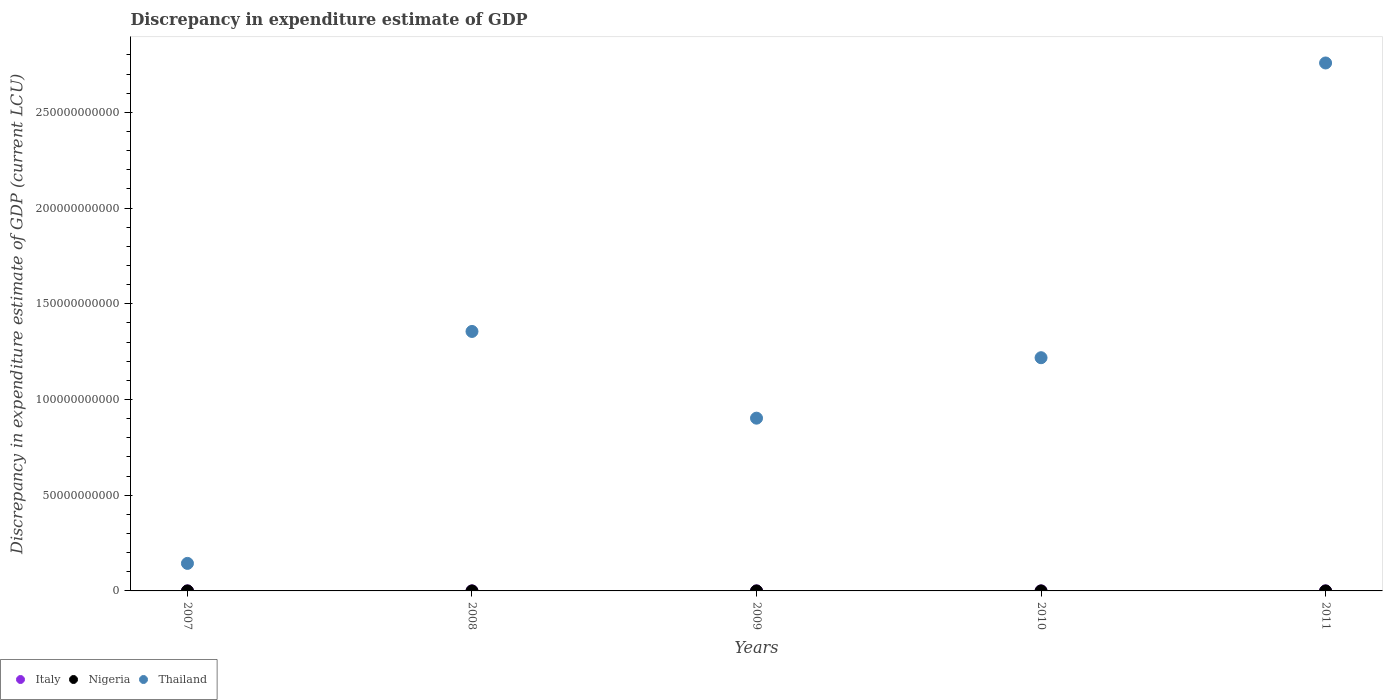Is the number of dotlines equal to the number of legend labels?
Your answer should be very brief. No. What is the discrepancy in expenditure estimate of GDP in Thailand in 2007?
Provide a succinct answer. 1.44e+1. Across all years, what is the maximum discrepancy in expenditure estimate of GDP in Nigeria?
Your answer should be very brief. 1.40e+05. Across all years, what is the minimum discrepancy in expenditure estimate of GDP in Thailand?
Make the answer very short. 1.44e+1. What is the total discrepancy in expenditure estimate of GDP in Italy in the graph?
Make the answer very short. 6.46e+04. What is the difference between the discrepancy in expenditure estimate of GDP in Italy in 2008 and that in 2011?
Make the answer very short. 4.16e+04. What is the difference between the discrepancy in expenditure estimate of GDP in Thailand in 2008 and the discrepancy in expenditure estimate of GDP in Nigeria in 2007?
Provide a succinct answer. 1.36e+11. What is the average discrepancy in expenditure estimate of GDP in Italy per year?
Your answer should be very brief. 1.29e+04. In the year 2008, what is the difference between the discrepancy in expenditure estimate of GDP in Italy and discrepancy in expenditure estimate of GDP in Nigeria?
Your answer should be very brief. -9.37e+04. What is the ratio of the discrepancy in expenditure estimate of GDP in Thailand in 2007 to that in 2009?
Provide a succinct answer. 0.16. What is the difference between the highest and the second highest discrepancy in expenditure estimate of GDP in Thailand?
Offer a very short reply. 1.40e+11. What is the difference between the highest and the lowest discrepancy in expenditure estimate of GDP in Nigeria?
Your answer should be compact. 1.40e+05. Is the sum of the discrepancy in expenditure estimate of GDP in Italy in 2008 and 2009 greater than the maximum discrepancy in expenditure estimate of GDP in Thailand across all years?
Provide a short and direct response. No. Is it the case that in every year, the sum of the discrepancy in expenditure estimate of GDP in Thailand and discrepancy in expenditure estimate of GDP in Italy  is greater than the discrepancy in expenditure estimate of GDP in Nigeria?
Offer a very short reply. Yes. Is the discrepancy in expenditure estimate of GDP in Italy strictly greater than the discrepancy in expenditure estimate of GDP in Thailand over the years?
Provide a succinct answer. No. Is the discrepancy in expenditure estimate of GDP in Nigeria strictly less than the discrepancy in expenditure estimate of GDP in Italy over the years?
Offer a terse response. No. How many years are there in the graph?
Your response must be concise. 5. How many legend labels are there?
Your answer should be compact. 3. What is the title of the graph?
Provide a short and direct response. Discrepancy in expenditure estimate of GDP. What is the label or title of the Y-axis?
Your answer should be very brief. Discrepancy in expenditure estimate of GDP (current LCU). What is the Discrepancy in expenditure estimate of GDP (current LCU) of Nigeria in 2007?
Give a very brief answer. 0. What is the Discrepancy in expenditure estimate of GDP (current LCU) of Thailand in 2007?
Make the answer very short. 1.44e+1. What is the Discrepancy in expenditure estimate of GDP (current LCU) in Italy in 2008?
Provide a short and direct response. 4.63e+04. What is the Discrepancy in expenditure estimate of GDP (current LCU) in Nigeria in 2008?
Provide a succinct answer. 1.40e+05. What is the Discrepancy in expenditure estimate of GDP (current LCU) in Thailand in 2008?
Your answer should be very brief. 1.36e+11. What is the Discrepancy in expenditure estimate of GDP (current LCU) in Italy in 2009?
Ensure brevity in your answer.  1.36e+04. What is the Discrepancy in expenditure estimate of GDP (current LCU) in Nigeria in 2009?
Your answer should be compact. 0. What is the Discrepancy in expenditure estimate of GDP (current LCU) in Thailand in 2009?
Ensure brevity in your answer.  9.02e+1. What is the Discrepancy in expenditure estimate of GDP (current LCU) of Italy in 2010?
Offer a terse response. 0. What is the Discrepancy in expenditure estimate of GDP (current LCU) in Thailand in 2010?
Offer a terse response. 1.22e+11. What is the Discrepancy in expenditure estimate of GDP (current LCU) in Italy in 2011?
Your answer should be very brief. 4700. What is the Discrepancy in expenditure estimate of GDP (current LCU) in Nigeria in 2011?
Your answer should be very brief. 0. What is the Discrepancy in expenditure estimate of GDP (current LCU) of Thailand in 2011?
Give a very brief answer. 2.76e+11. Across all years, what is the maximum Discrepancy in expenditure estimate of GDP (current LCU) of Italy?
Offer a terse response. 4.63e+04. Across all years, what is the maximum Discrepancy in expenditure estimate of GDP (current LCU) of Nigeria?
Ensure brevity in your answer.  1.40e+05. Across all years, what is the maximum Discrepancy in expenditure estimate of GDP (current LCU) of Thailand?
Give a very brief answer. 2.76e+11. Across all years, what is the minimum Discrepancy in expenditure estimate of GDP (current LCU) in Thailand?
Make the answer very short. 1.44e+1. What is the total Discrepancy in expenditure estimate of GDP (current LCU) of Italy in the graph?
Make the answer very short. 6.46e+04. What is the total Discrepancy in expenditure estimate of GDP (current LCU) of Nigeria in the graph?
Offer a very short reply. 1.40e+05. What is the total Discrepancy in expenditure estimate of GDP (current LCU) of Thailand in the graph?
Make the answer very short. 6.38e+11. What is the difference between the Discrepancy in expenditure estimate of GDP (current LCU) in Thailand in 2007 and that in 2008?
Your answer should be compact. -1.21e+11. What is the difference between the Discrepancy in expenditure estimate of GDP (current LCU) of Thailand in 2007 and that in 2009?
Offer a very short reply. -7.59e+1. What is the difference between the Discrepancy in expenditure estimate of GDP (current LCU) of Thailand in 2007 and that in 2010?
Your answer should be very brief. -1.07e+11. What is the difference between the Discrepancy in expenditure estimate of GDP (current LCU) in Thailand in 2007 and that in 2011?
Your answer should be very brief. -2.61e+11. What is the difference between the Discrepancy in expenditure estimate of GDP (current LCU) of Italy in 2008 and that in 2009?
Your answer should be very brief. 3.27e+04. What is the difference between the Discrepancy in expenditure estimate of GDP (current LCU) in Thailand in 2008 and that in 2009?
Ensure brevity in your answer.  4.53e+1. What is the difference between the Discrepancy in expenditure estimate of GDP (current LCU) in Thailand in 2008 and that in 2010?
Make the answer very short. 1.37e+1. What is the difference between the Discrepancy in expenditure estimate of GDP (current LCU) in Italy in 2008 and that in 2011?
Keep it short and to the point. 4.16e+04. What is the difference between the Discrepancy in expenditure estimate of GDP (current LCU) in Thailand in 2008 and that in 2011?
Provide a succinct answer. -1.40e+11. What is the difference between the Discrepancy in expenditure estimate of GDP (current LCU) in Thailand in 2009 and that in 2010?
Make the answer very short. -3.16e+1. What is the difference between the Discrepancy in expenditure estimate of GDP (current LCU) in Italy in 2009 and that in 2011?
Offer a very short reply. 8900. What is the difference between the Discrepancy in expenditure estimate of GDP (current LCU) of Thailand in 2009 and that in 2011?
Provide a short and direct response. -1.86e+11. What is the difference between the Discrepancy in expenditure estimate of GDP (current LCU) of Thailand in 2010 and that in 2011?
Offer a very short reply. -1.54e+11. What is the difference between the Discrepancy in expenditure estimate of GDP (current LCU) in Italy in 2008 and the Discrepancy in expenditure estimate of GDP (current LCU) in Thailand in 2009?
Your answer should be very brief. -9.02e+1. What is the difference between the Discrepancy in expenditure estimate of GDP (current LCU) of Nigeria in 2008 and the Discrepancy in expenditure estimate of GDP (current LCU) of Thailand in 2009?
Your response must be concise. -9.02e+1. What is the difference between the Discrepancy in expenditure estimate of GDP (current LCU) of Italy in 2008 and the Discrepancy in expenditure estimate of GDP (current LCU) of Thailand in 2010?
Your answer should be very brief. -1.22e+11. What is the difference between the Discrepancy in expenditure estimate of GDP (current LCU) of Nigeria in 2008 and the Discrepancy in expenditure estimate of GDP (current LCU) of Thailand in 2010?
Offer a very short reply. -1.22e+11. What is the difference between the Discrepancy in expenditure estimate of GDP (current LCU) of Italy in 2008 and the Discrepancy in expenditure estimate of GDP (current LCU) of Thailand in 2011?
Ensure brevity in your answer.  -2.76e+11. What is the difference between the Discrepancy in expenditure estimate of GDP (current LCU) of Nigeria in 2008 and the Discrepancy in expenditure estimate of GDP (current LCU) of Thailand in 2011?
Provide a succinct answer. -2.76e+11. What is the difference between the Discrepancy in expenditure estimate of GDP (current LCU) of Italy in 2009 and the Discrepancy in expenditure estimate of GDP (current LCU) of Thailand in 2010?
Keep it short and to the point. -1.22e+11. What is the difference between the Discrepancy in expenditure estimate of GDP (current LCU) in Italy in 2009 and the Discrepancy in expenditure estimate of GDP (current LCU) in Thailand in 2011?
Offer a very short reply. -2.76e+11. What is the average Discrepancy in expenditure estimate of GDP (current LCU) of Italy per year?
Your response must be concise. 1.29e+04. What is the average Discrepancy in expenditure estimate of GDP (current LCU) in Nigeria per year?
Offer a terse response. 2.80e+04. What is the average Discrepancy in expenditure estimate of GDP (current LCU) in Thailand per year?
Keep it short and to the point. 1.28e+11. In the year 2008, what is the difference between the Discrepancy in expenditure estimate of GDP (current LCU) in Italy and Discrepancy in expenditure estimate of GDP (current LCU) in Nigeria?
Give a very brief answer. -9.37e+04. In the year 2008, what is the difference between the Discrepancy in expenditure estimate of GDP (current LCU) in Italy and Discrepancy in expenditure estimate of GDP (current LCU) in Thailand?
Ensure brevity in your answer.  -1.36e+11. In the year 2008, what is the difference between the Discrepancy in expenditure estimate of GDP (current LCU) in Nigeria and Discrepancy in expenditure estimate of GDP (current LCU) in Thailand?
Make the answer very short. -1.36e+11. In the year 2009, what is the difference between the Discrepancy in expenditure estimate of GDP (current LCU) of Italy and Discrepancy in expenditure estimate of GDP (current LCU) of Thailand?
Give a very brief answer. -9.02e+1. In the year 2011, what is the difference between the Discrepancy in expenditure estimate of GDP (current LCU) in Italy and Discrepancy in expenditure estimate of GDP (current LCU) in Thailand?
Give a very brief answer. -2.76e+11. What is the ratio of the Discrepancy in expenditure estimate of GDP (current LCU) in Thailand in 2007 to that in 2008?
Give a very brief answer. 0.11. What is the ratio of the Discrepancy in expenditure estimate of GDP (current LCU) of Thailand in 2007 to that in 2009?
Your answer should be very brief. 0.16. What is the ratio of the Discrepancy in expenditure estimate of GDP (current LCU) of Thailand in 2007 to that in 2010?
Offer a terse response. 0.12. What is the ratio of the Discrepancy in expenditure estimate of GDP (current LCU) in Thailand in 2007 to that in 2011?
Ensure brevity in your answer.  0.05. What is the ratio of the Discrepancy in expenditure estimate of GDP (current LCU) in Italy in 2008 to that in 2009?
Provide a succinct answer. 3.4. What is the ratio of the Discrepancy in expenditure estimate of GDP (current LCU) in Thailand in 2008 to that in 2009?
Give a very brief answer. 1.5. What is the ratio of the Discrepancy in expenditure estimate of GDP (current LCU) of Thailand in 2008 to that in 2010?
Ensure brevity in your answer.  1.11. What is the ratio of the Discrepancy in expenditure estimate of GDP (current LCU) in Italy in 2008 to that in 2011?
Make the answer very short. 9.85. What is the ratio of the Discrepancy in expenditure estimate of GDP (current LCU) in Thailand in 2008 to that in 2011?
Your answer should be compact. 0.49. What is the ratio of the Discrepancy in expenditure estimate of GDP (current LCU) in Thailand in 2009 to that in 2010?
Make the answer very short. 0.74. What is the ratio of the Discrepancy in expenditure estimate of GDP (current LCU) of Italy in 2009 to that in 2011?
Keep it short and to the point. 2.89. What is the ratio of the Discrepancy in expenditure estimate of GDP (current LCU) of Thailand in 2009 to that in 2011?
Ensure brevity in your answer.  0.33. What is the ratio of the Discrepancy in expenditure estimate of GDP (current LCU) of Thailand in 2010 to that in 2011?
Give a very brief answer. 0.44. What is the difference between the highest and the second highest Discrepancy in expenditure estimate of GDP (current LCU) in Italy?
Ensure brevity in your answer.  3.27e+04. What is the difference between the highest and the second highest Discrepancy in expenditure estimate of GDP (current LCU) of Thailand?
Offer a terse response. 1.40e+11. What is the difference between the highest and the lowest Discrepancy in expenditure estimate of GDP (current LCU) in Italy?
Ensure brevity in your answer.  4.63e+04. What is the difference between the highest and the lowest Discrepancy in expenditure estimate of GDP (current LCU) of Nigeria?
Offer a terse response. 1.40e+05. What is the difference between the highest and the lowest Discrepancy in expenditure estimate of GDP (current LCU) in Thailand?
Keep it short and to the point. 2.61e+11. 